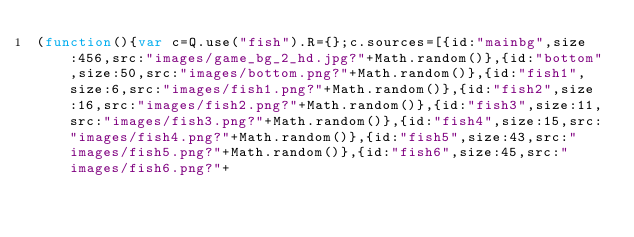<code> <loc_0><loc_0><loc_500><loc_500><_JavaScript_>(function(){var c=Q.use("fish").R={};c.sources=[{id:"mainbg",size:456,src:"images/game_bg_2_hd.jpg?"+Math.random()},{id:"bottom",size:50,src:"images/bottom.png?"+Math.random()},{id:"fish1",size:6,src:"images/fish1.png?"+Math.random()},{id:"fish2",size:16,src:"images/fish2.png?"+Math.random()},{id:"fish3",size:11,src:"images/fish3.png?"+Math.random()},{id:"fish4",size:15,src:"images/fish4.png?"+Math.random()},{id:"fish5",size:43,src:"images/fish5.png?"+Math.random()},{id:"fish6",size:45,src:"images/fish6.png?"+</code> 